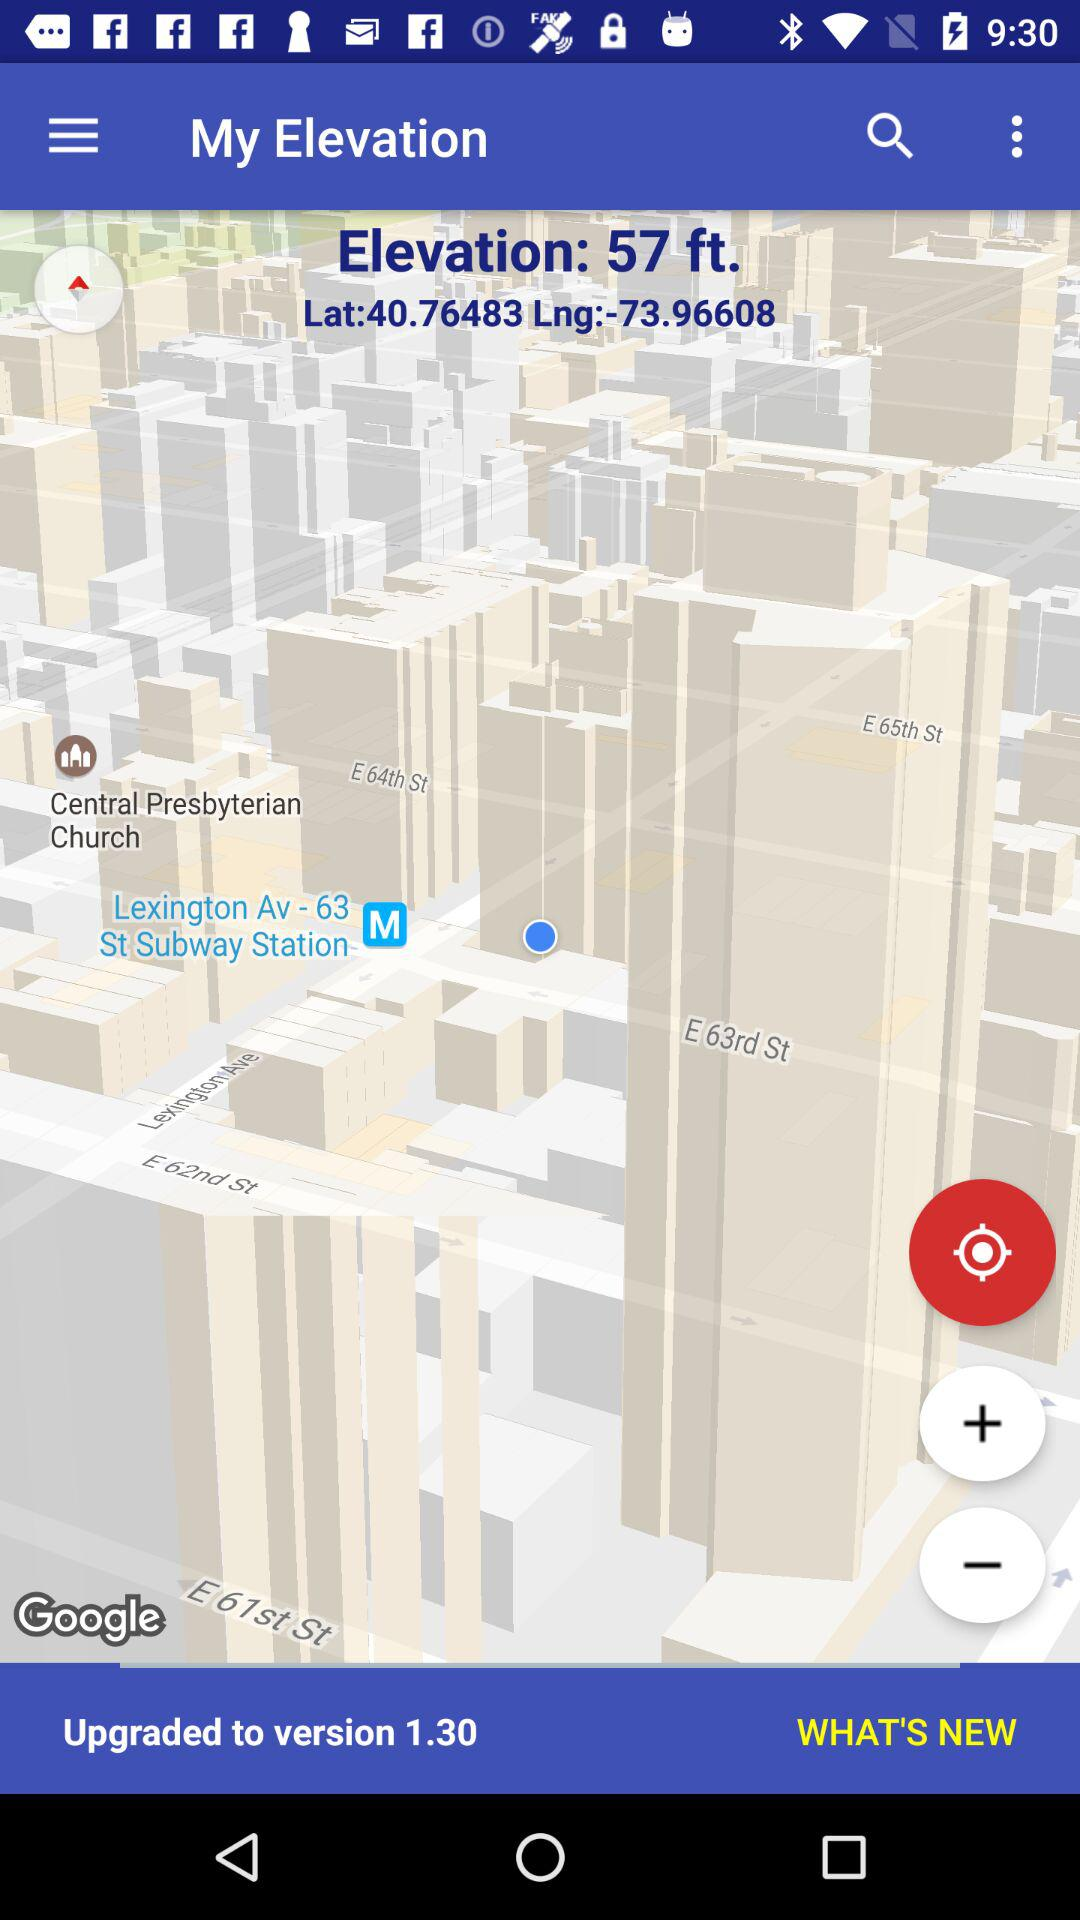What is the longitude? The longitude is 73.96608. 